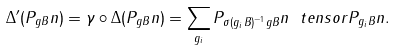Convert formula to latex. <formula><loc_0><loc_0><loc_500><loc_500>\Delta ^ { \prime } ( P _ { g B } n ) = \gamma \circ \Delta ( P _ { g B } n ) = \sum _ { g _ { i } } P _ { \sigma ( g _ { i } B ) ^ { - 1 } g B } n \ t e n s o r P _ { g _ { i } B } n .</formula> 